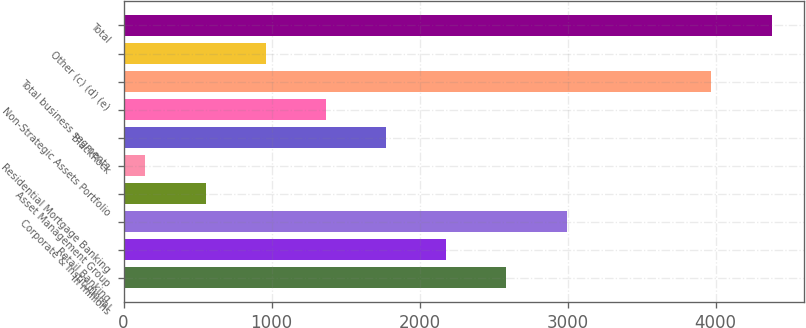<chart> <loc_0><loc_0><loc_500><loc_500><bar_chart><fcel>In millions<fcel>Retail Banking<fcel>Corporate & Institutional<fcel>Asset Management Group<fcel>Residential Mortgage Banking<fcel>BlackRock<fcel>Non-Strategic Assets Portfolio<fcel>Total business segments<fcel>Other (c) (d) (e)<fcel>Total<nl><fcel>2586.4<fcel>2180<fcel>2992.8<fcel>554.4<fcel>148<fcel>1773.6<fcel>1367.2<fcel>3972<fcel>960.8<fcel>4378.4<nl></chart> 